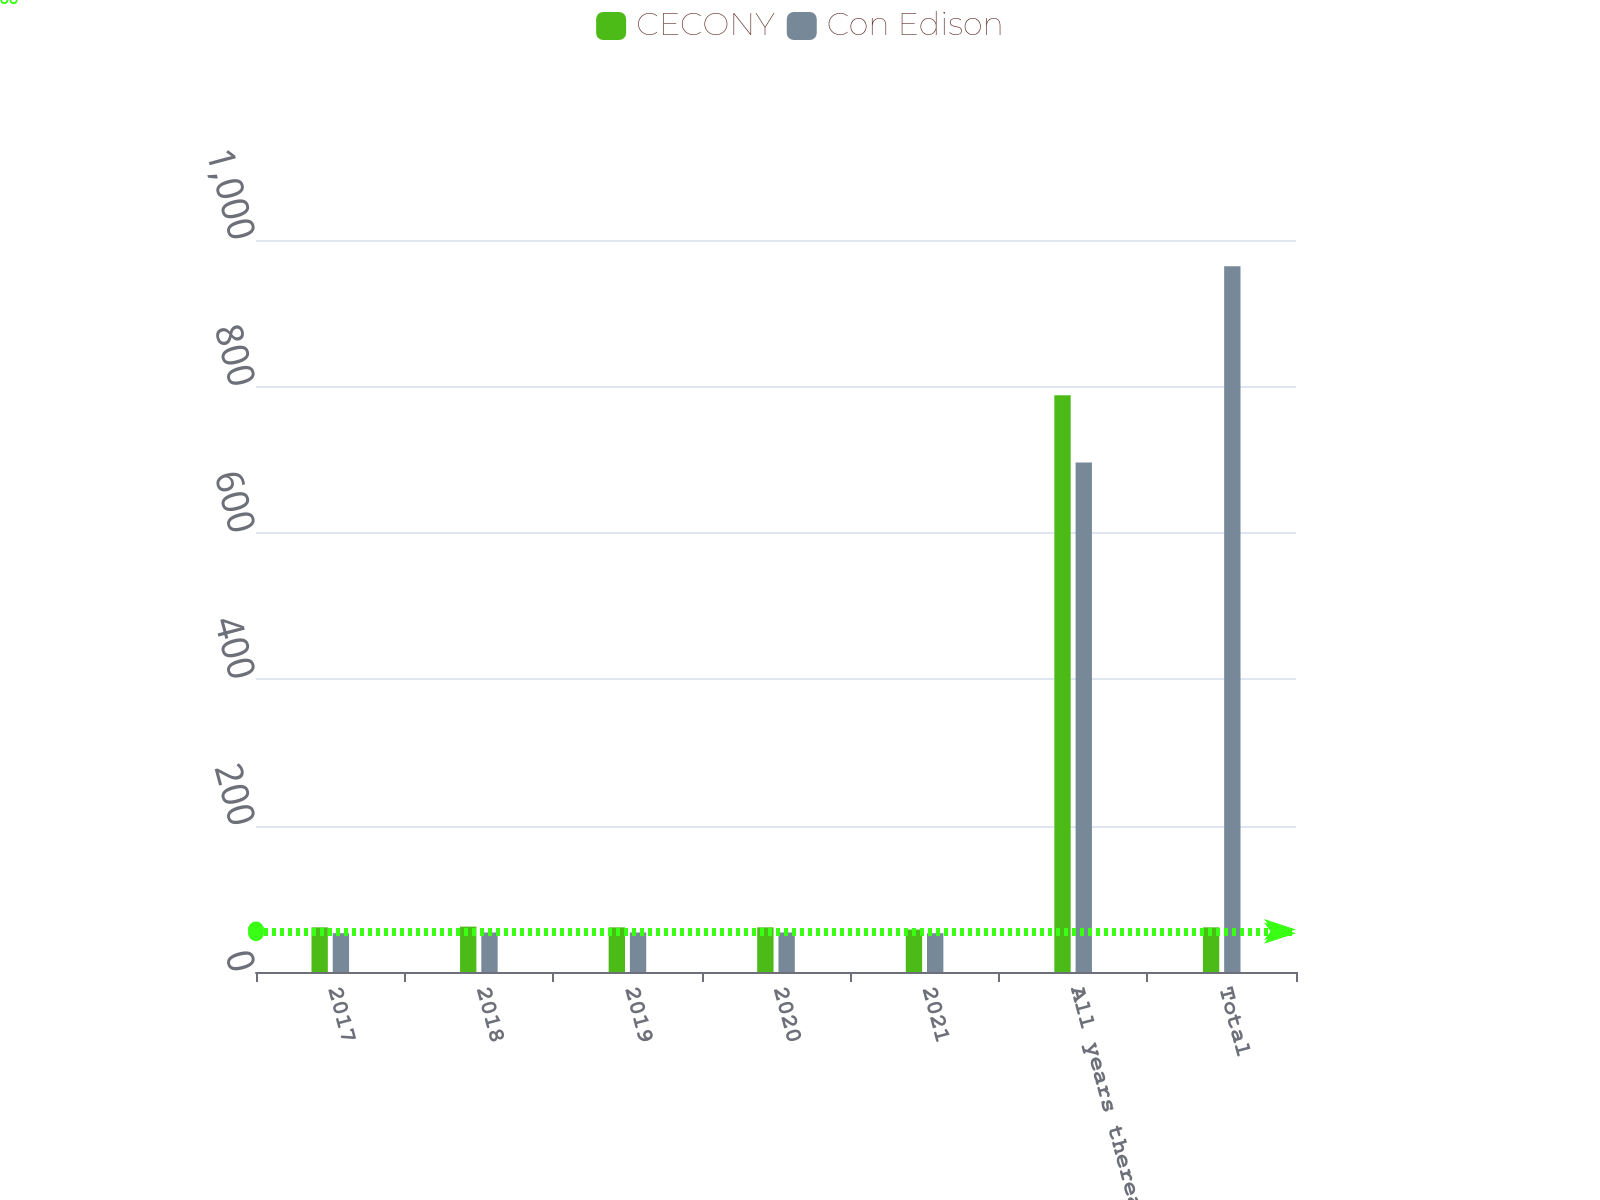<chart> <loc_0><loc_0><loc_500><loc_500><stacked_bar_chart><ecel><fcel>2017<fcel>2018<fcel>2019<fcel>2020<fcel>2021<fcel>All years thereafter<fcel>Total<nl><fcel>CECONY<fcel>61<fcel>62<fcel>61<fcel>61<fcel>58<fcel>788<fcel>61<nl><fcel>Con Edison<fcel>53<fcel>54<fcel>54<fcel>54<fcel>53<fcel>696<fcel>964<nl></chart> 